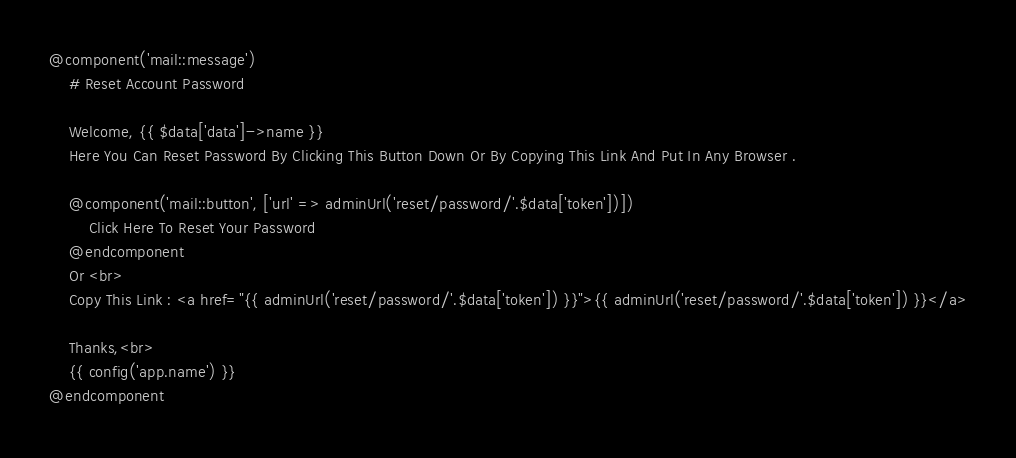<code> <loc_0><loc_0><loc_500><loc_500><_PHP_>@component('mail::message')
    # Reset Account Password

    Welcome, {{ $data['data']->name }}
    Here You Can Reset Password By Clicking This Button Down Or By Copying This Link And Put In Any Browser .

    @component('mail::button', ['url' => adminUrl('reset/password/'.$data['token'])])
        Click Here To Reset Your Password
    @endcomponent
    Or <br>
    Copy This Link : <a href="{{ adminUrl('reset/password/'.$data['token']) }}">{{ adminUrl('reset/password/'.$data['token']) }}</a>

    Thanks,<br>
    {{ config('app.name') }}
@endcomponent
</code> 